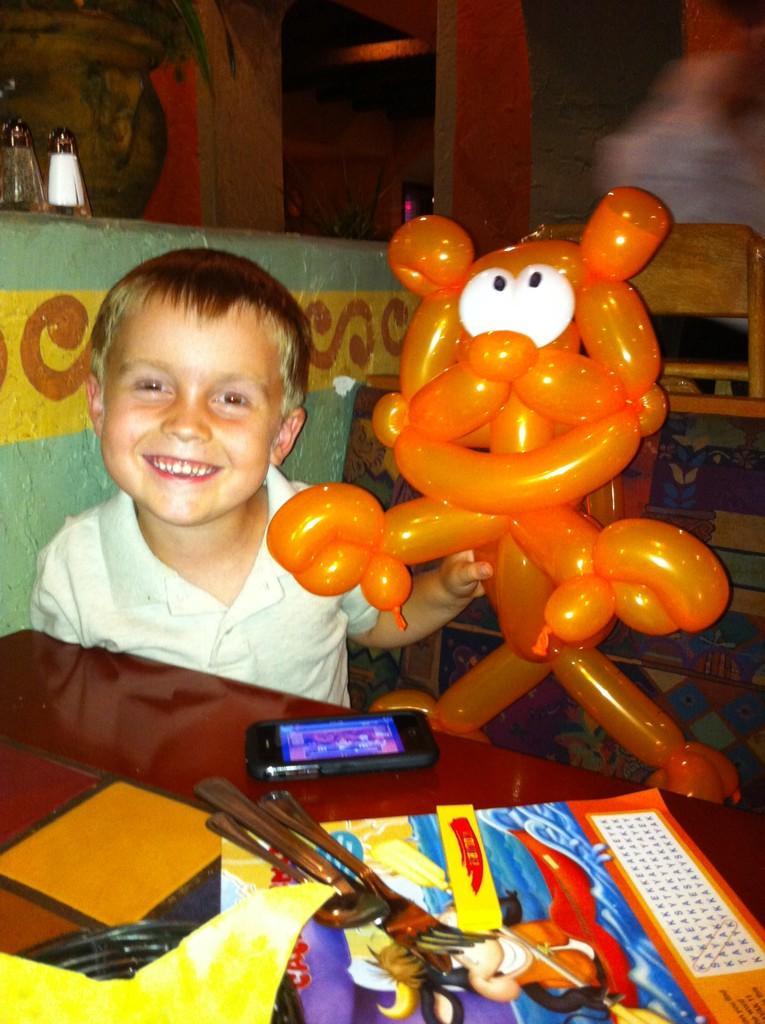How would you summarize this image in a sentence or two? In this image there is one kid at left side of this image is smiling and holding a balloon and there is a wall in the background, and there are some objects kept on a table at bottom of this image and there is a mobile in middle of this image. There are some objects kept at top left side of this image. 